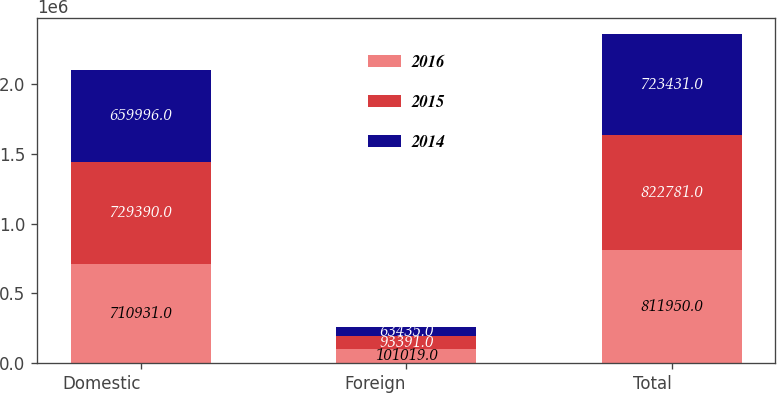<chart> <loc_0><loc_0><loc_500><loc_500><stacked_bar_chart><ecel><fcel>Domestic<fcel>Foreign<fcel>Total<nl><fcel>2016<fcel>710931<fcel>101019<fcel>811950<nl><fcel>2015<fcel>729390<fcel>93391<fcel>822781<nl><fcel>2014<fcel>659996<fcel>63435<fcel>723431<nl></chart> 